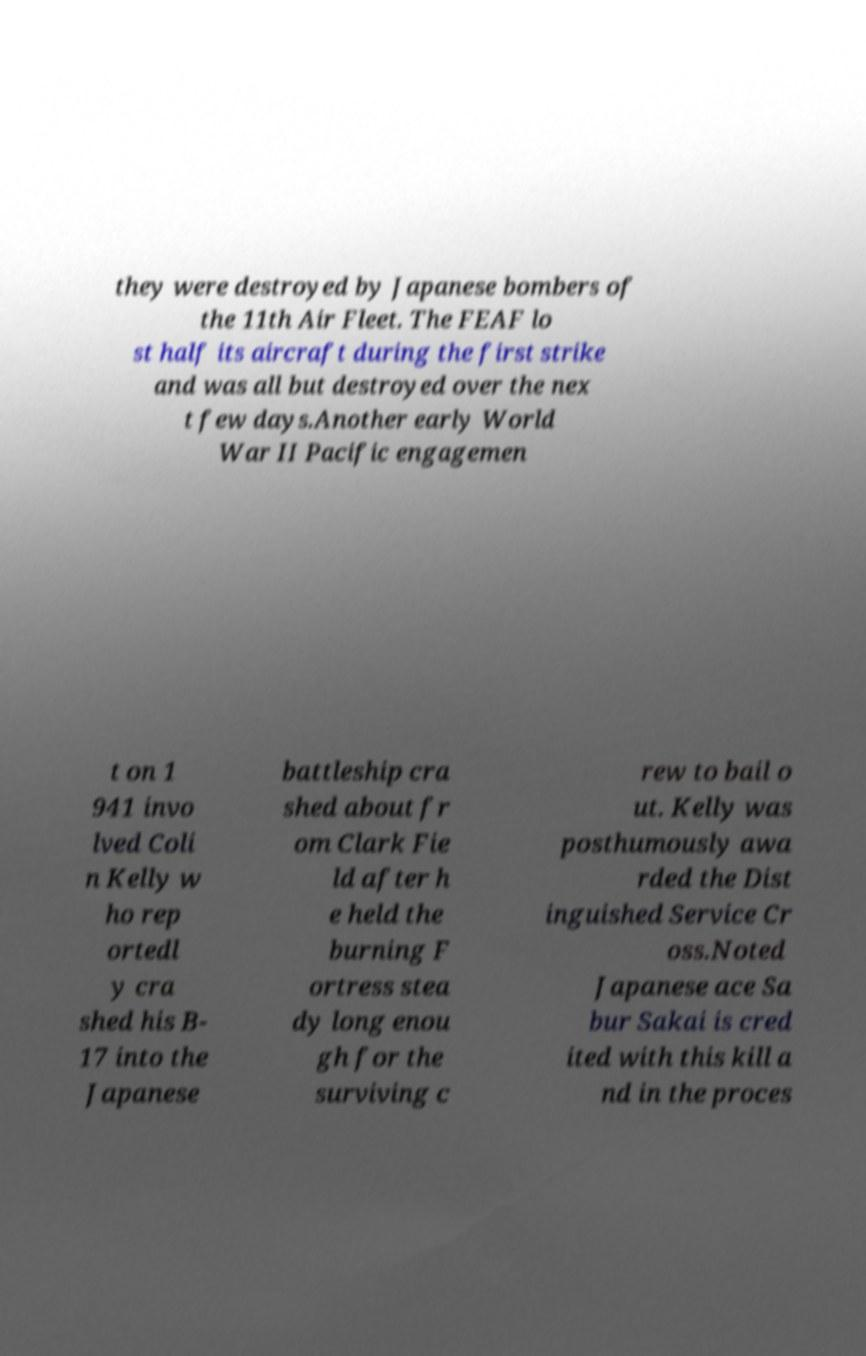Could you extract and type out the text from this image? they were destroyed by Japanese bombers of the 11th Air Fleet. The FEAF lo st half its aircraft during the first strike and was all but destroyed over the nex t few days.Another early World War II Pacific engagemen t on 1 941 invo lved Coli n Kelly w ho rep ortedl y cra shed his B- 17 into the Japanese battleship cra shed about fr om Clark Fie ld after h e held the burning F ortress stea dy long enou gh for the surviving c rew to bail o ut. Kelly was posthumously awa rded the Dist inguished Service Cr oss.Noted Japanese ace Sa bur Sakai is cred ited with this kill a nd in the proces 